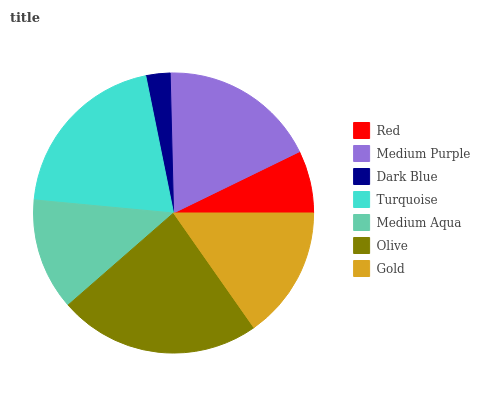Is Dark Blue the minimum?
Answer yes or no. Yes. Is Olive the maximum?
Answer yes or no. Yes. Is Medium Purple the minimum?
Answer yes or no. No. Is Medium Purple the maximum?
Answer yes or no. No. Is Medium Purple greater than Red?
Answer yes or no. Yes. Is Red less than Medium Purple?
Answer yes or no. Yes. Is Red greater than Medium Purple?
Answer yes or no. No. Is Medium Purple less than Red?
Answer yes or no. No. Is Gold the high median?
Answer yes or no. Yes. Is Gold the low median?
Answer yes or no. Yes. Is Turquoise the high median?
Answer yes or no. No. Is Turquoise the low median?
Answer yes or no. No. 